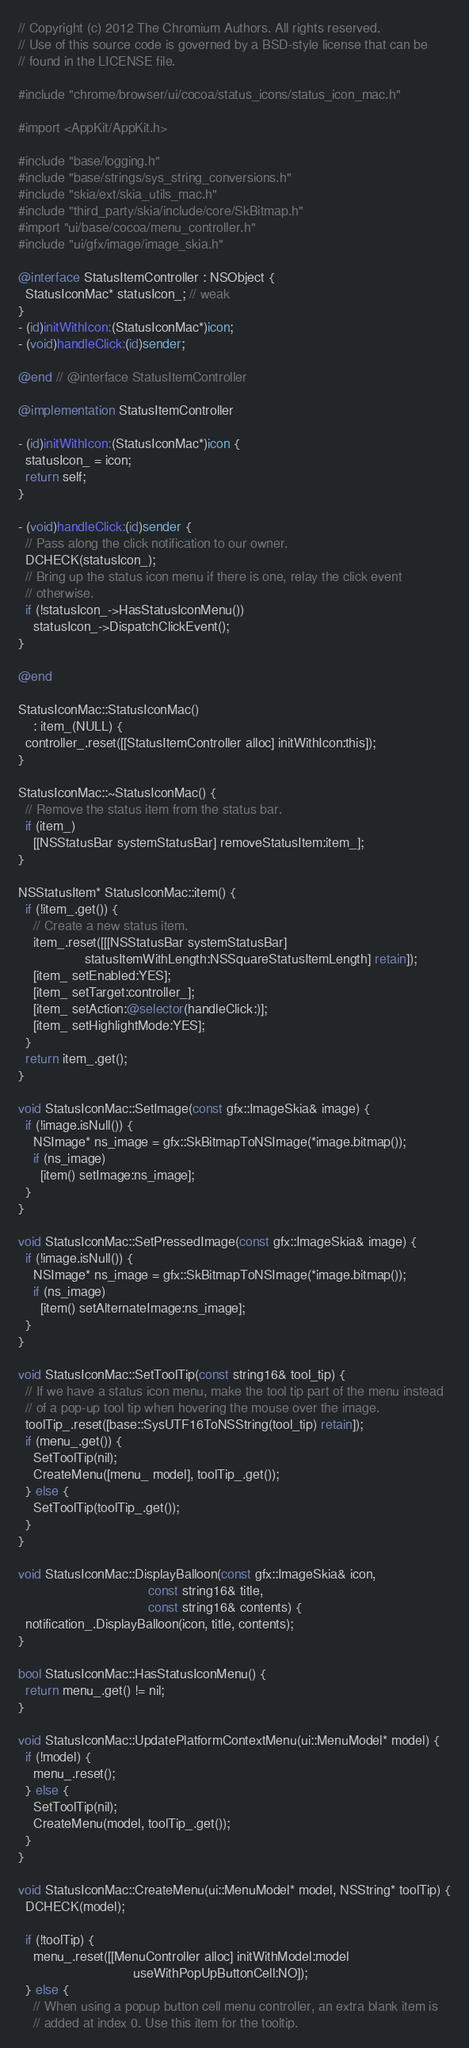<code> <loc_0><loc_0><loc_500><loc_500><_ObjectiveC_>// Copyright (c) 2012 The Chromium Authors. All rights reserved.
// Use of this source code is governed by a BSD-style license that can be
// found in the LICENSE file.

#include "chrome/browser/ui/cocoa/status_icons/status_icon_mac.h"

#import <AppKit/AppKit.h>

#include "base/logging.h"
#include "base/strings/sys_string_conversions.h"
#include "skia/ext/skia_utils_mac.h"
#include "third_party/skia/include/core/SkBitmap.h"
#import "ui/base/cocoa/menu_controller.h"
#include "ui/gfx/image/image_skia.h"

@interface StatusItemController : NSObject {
  StatusIconMac* statusIcon_; // weak
}
- (id)initWithIcon:(StatusIconMac*)icon;
- (void)handleClick:(id)sender;

@end // @interface StatusItemController

@implementation StatusItemController

- (id)initWithIcon:(StatusIconMac*)icon {
  statusIcon_ = icon;
  return self;
}

- (void)handleClick:(id)sender {
  // Pass along the click notification to our owner.
  DCHECK(statusIcon_);
  // Bring up the status icon menu if there is one, relay the click event
  // otherwise.
  if (!statusIcon_->HasStatusIconMenu())
    statusIcon_->DispatchClickEvent();
}

@end

StatusIconMac::StatusIconMac()
    : item_(NULL) {
  controller_.reset([[StatusItemController alloc] initWithIcon:this]);
}

StatusIconMac::~StatusIconMac() {
  // Remove the status item from the status bar.
  if (item_)
    [[NSStatusBar systemStatusBar] removeStatusItem:item_];
}

NSStatusItem* StatusIconMac::item() {
  if (!item_.get()) {
    // Create a new status item.
    item_.reset([[[NSStatusBar systemStatusBar]
                  statusItemWithLength:NSSquareStatusItemLength] retain]);
    [item_ setEnabled:YES];
    [item_ setTarget:controller_];
    [item_ setAction:@selector(handleClick:)];
    [item_ setHighlightMode:YES];
  }
  return item_.get();
}

void StatusIconMac::SetImage(const gfx::ImageSkia& image) {
  if (!image.isNull()) {
    NSImage* ns_image = gfx::SkBitmapToNSImage(*image.bitmap());
    if (ns_image)
      [item() setImage:ns_image];
  }
}

void StatusIconMac::SetPressedImage(const gfx::ImageSkia& image) {
  if (!image.isNull()) {
    NSImage* ns_image = gfx::SkBitmapToNSImage(*image.bitmap());
    if (ns_image)
      [item() setAlternateImage:ns_image];
  }
}

void StatusIconMac::SetToolTip(const string16& tool_tip) {
  // If we have a status icon menu, make the tool tip part of the menu instead
  // of a pop-up tool tip when hovering the mouse over the image.
  toolTip_.reset([base::SysUTF16ToNSString(tool_tip) retain]);
  if (menu_.get()) {
    SetToolTip(nil);
    CreateMenu([menu_ model], toolTip_.get());
  } else {
    SetToolTip(toolTip_.get());
  }
}

void StatusIconMac::DisplayBalloon(const gfx::ImageSkia& icon,
                                   const string16& title,
                                   const string16& contents) {
  notification_.DisplayBalloon(icon, title, contents);
}

bool StatusIconMac::HasStatusIconMenu() {
  return menu_.get() != nil;
}

void StatusIconMac::UpdatePlatformContextMenu(ui::MenuModel* model) {
  if (!model) {
    menu_.reset();
  } else {
    SetToolTip(nil);
    CreateMenu(model, toolTip_.get());
  }
}

void StatusIconMac::CreateMenu(ui::MenuModel* model, NSString* toolTip) {
  DCHECK(model);

  if (!toolTip) {
    menu_.reset([[MenuController alloc] initWithModel:model
                               useWithPopUpButtonCell:NO]);
  } else {
    // When using a popup button cell menu controller, an extra blank item is
    // added at index 0. Use this item for the tooltip.</code> 